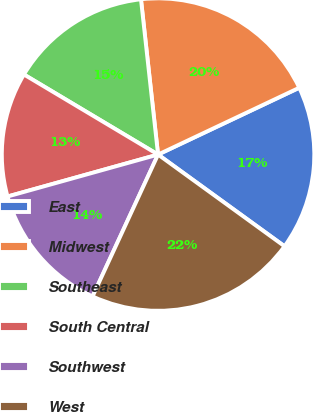<chart> <loc_0><loc_0><loc_500><loc_500><pie_chart><fcel>East<fcel>Midwest<fcel>Southeast<fcel>South Central<fcel>Southwest<fcel>West<nl><fcel>17.02%<fcel>19.71%<fcel>14.69%<fcel>12.89%<fcel>13.79%<fcel>21.9%<nl></chart> 